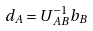<formula> <loc_0><loc_0><loc_500><loc_500>d _ { A } = U ^ { - 1 } _ { A B } b _ { B }</formula> 